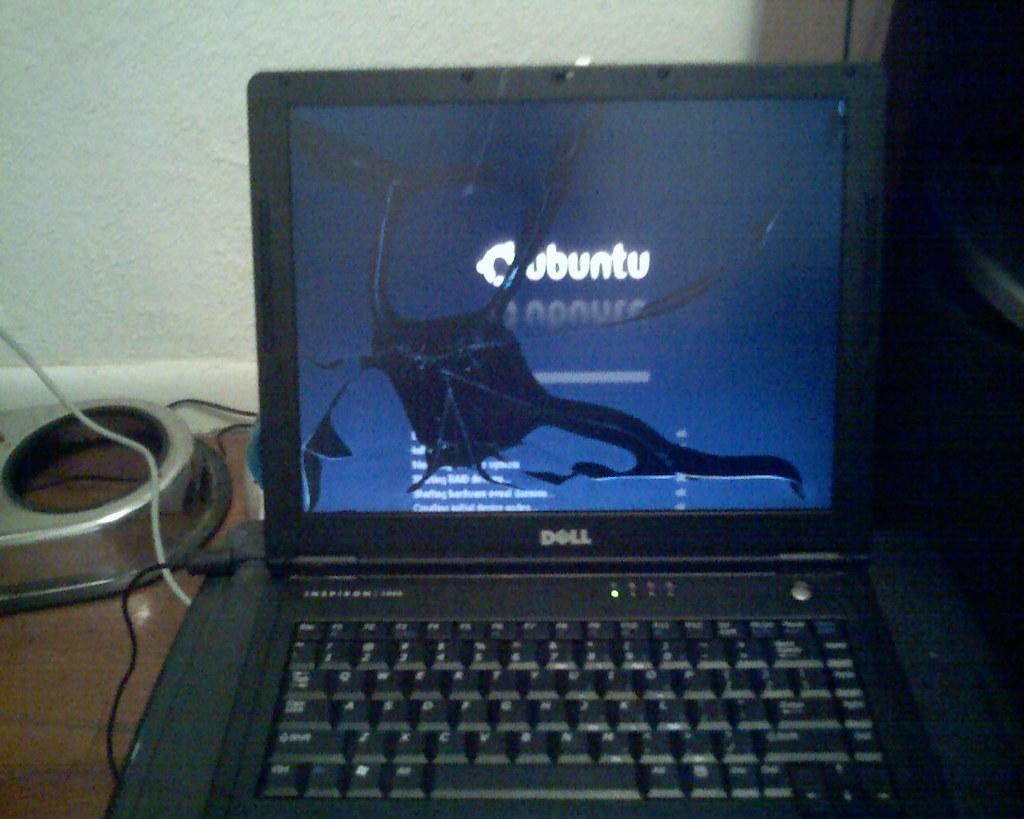<image>
Write a terse but informative summary of the picture. A dell computer screen is cracked and bleeding black 